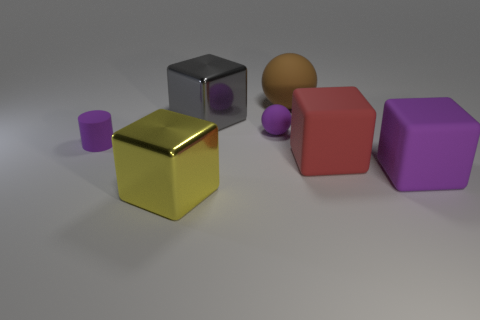Can you infer anything about the setting or context of these objects? Given the arrangement of these objects with distinct materials and colors on a neutral surface, it seems like a staged scene, possibly for a simulation or a study of materials, lighting, and shadow in a controlled environment. The absence of additional context cues such as background elements or items of known scale makes it challenging to discern any specific real-world setting. 